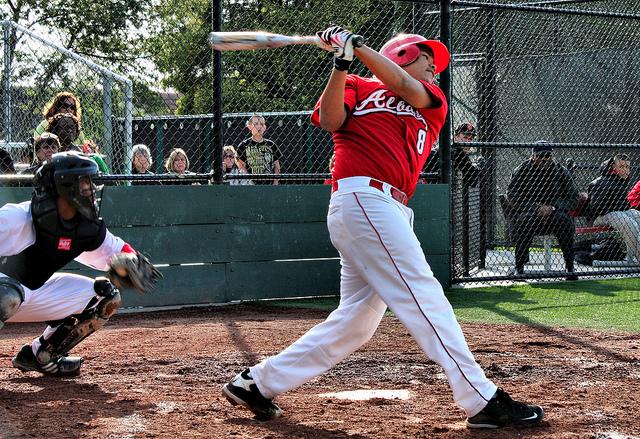What dance is like the motion this battery is making?
Be succinct. Twist. What is the players number?
Write a very short answer. 8. Is the catcher in motion right now?
Short answer required. Yes. 